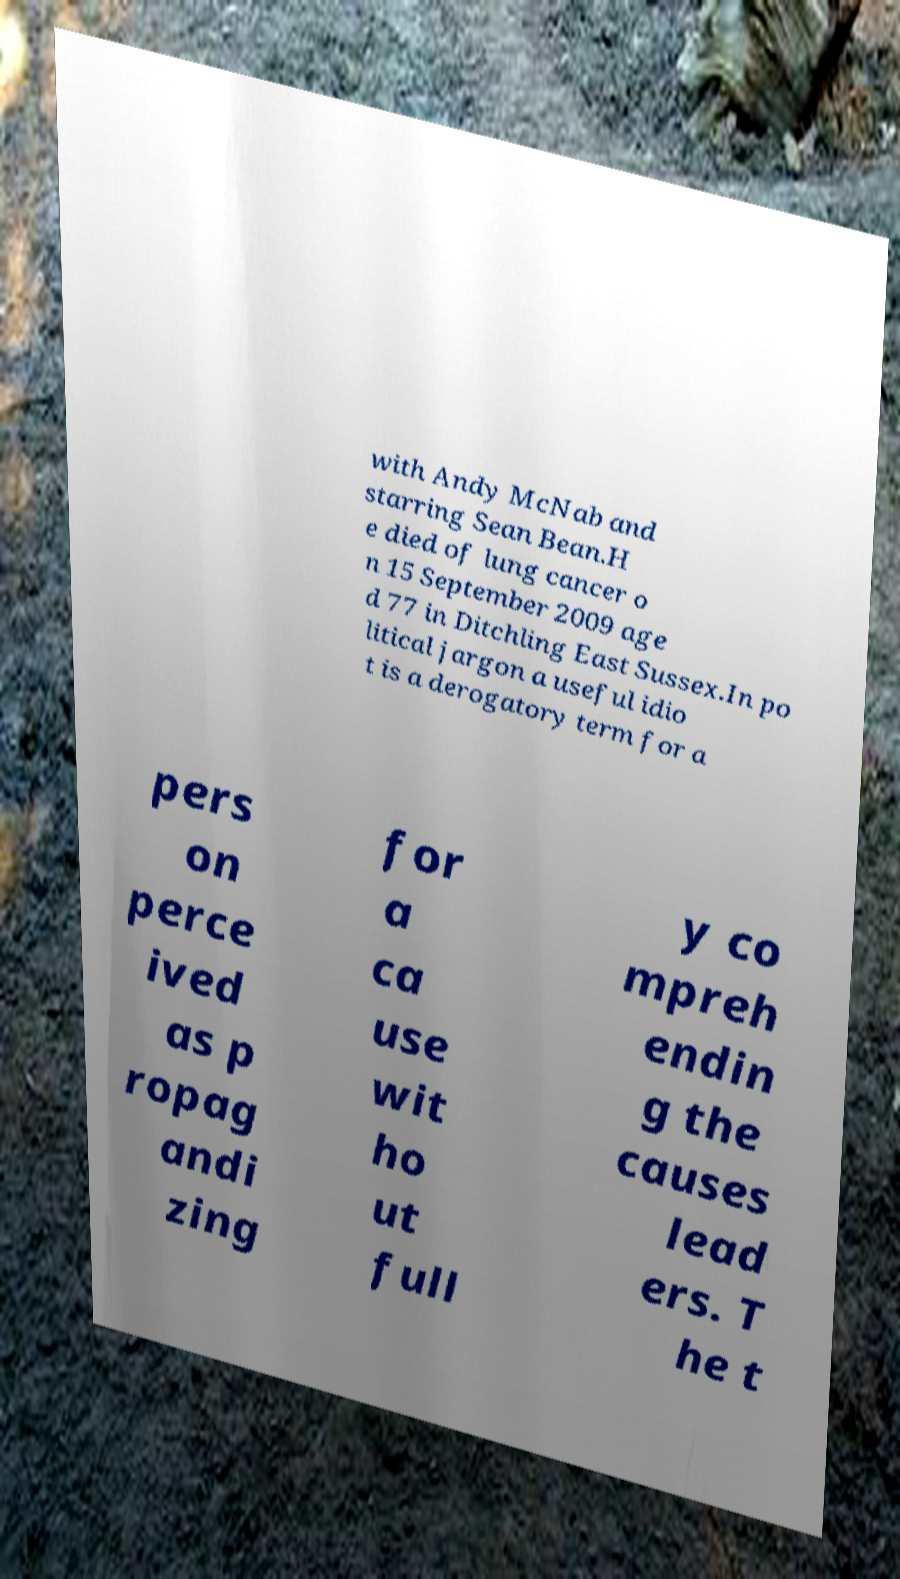Could you assist in decoding the text presented in this image and type it out clearly? with Andy McNab and starring Sean Bean.H e died of lung cancer o n 15 September 2009 age d 77 in Ditchling East Sussex.In po litical jargon a useful idio t is a derogatory term for a pers on perce ived as p ropag andi zing for a ca use wit ho ut full y co mpreh endin g the causes lead ers. T he t 